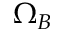<formula> <loc_0><loc_0><loc_500><loc_500>\Omega _ { B }</formula> 